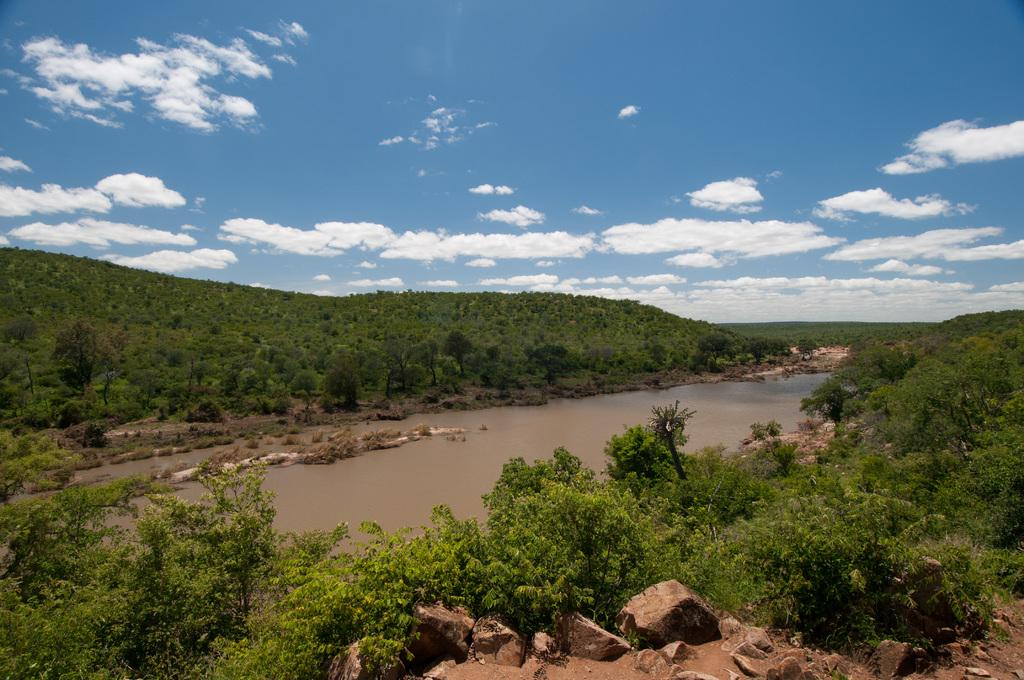What is the main subject in the center of the image? There is water in the center of the image. What can be seen in front of the image? There are rocks in front of the image. What type of vegetation is visible in the background? There are trees in the background of the image. What else can be seen in the background? There are clouds in the background of the image, and the sky is visible as well. What type of meal is being prepared in the water in the image? There is no meal being prepared in the water in the image; it is simply a body of water. 